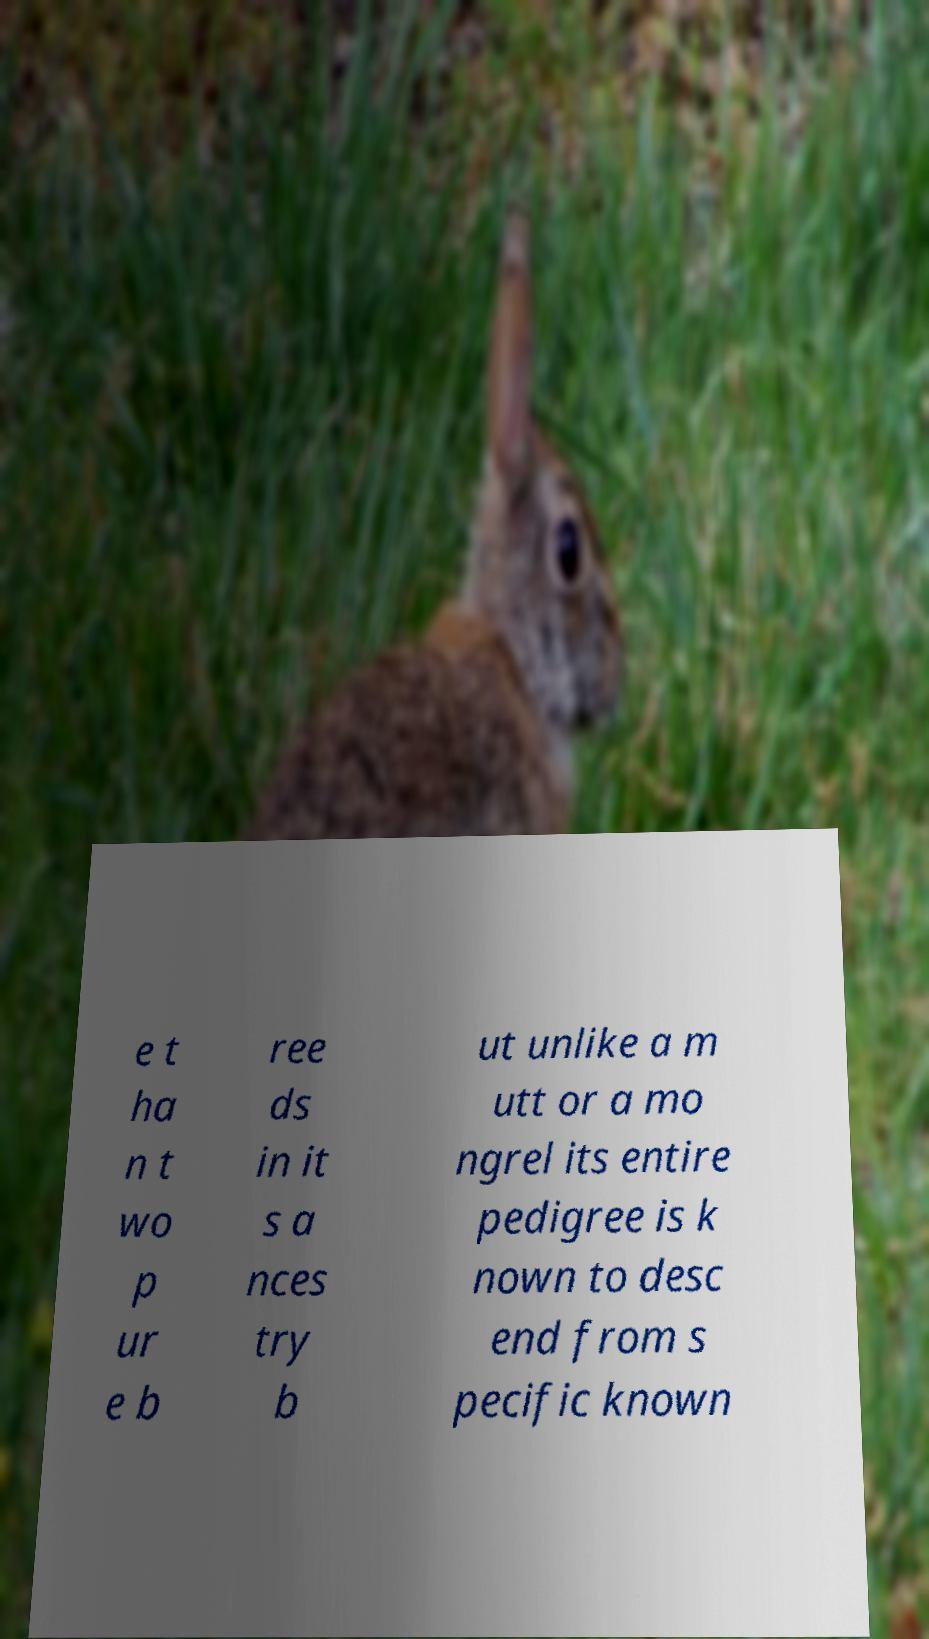Can you accurately transcribe the text from the provided image for me? e t ha n t wo p ur e b ree ds in it s a nces try b ut unlike a m utt or a mo ngrel its entire pedigree is k nown to desc end from s pecific known 